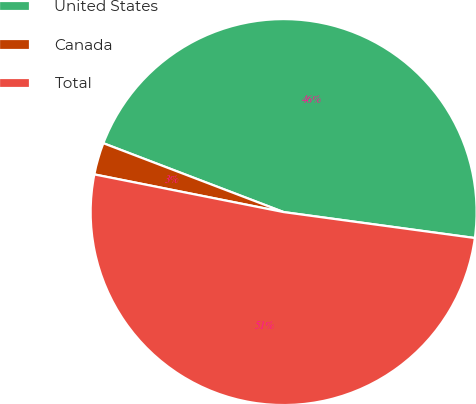Convert chart to OTSL. <chart><loc_0><loc_0><loc_500><loc_500><pie_chart><fcel>United States<fcel>Canada<fcel>Total<nl><fcel>46.34%<fcel>2.68%<fcel>50.98%<nl></chart> 